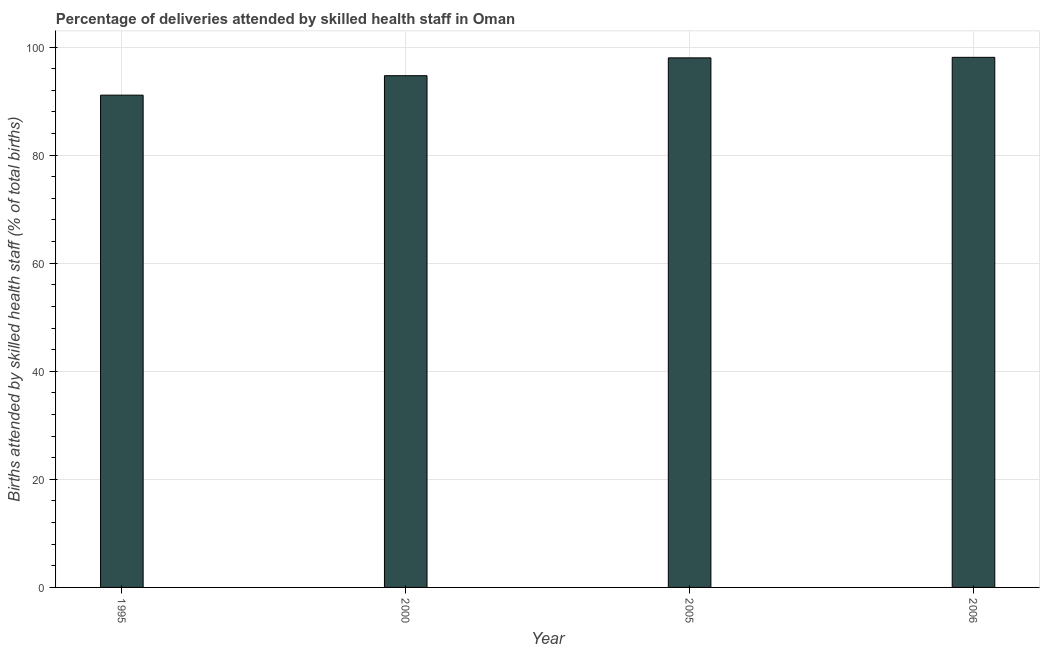Does the graph contain any zero values?
Offer a terse response. No. Does the graph contain grids?
Your answer should be compact. Yes. What is the title of the graph?
Provide a succinct answer. Percentage of deliveries attended by skilled health staff in Oman. What is the label or title of the X-axis?
Ensure brevity in your answer.  Year. What is the label or title of the Y-axis?
Give a very brief answer. Births attended by skilled health staff (% of total births). What is the number of births attended by skilled health staff in 2005?
Ensure brevity in your answer.  98. Across all years, what is the maximum number of births attended by skilled health staff?
Make the answer very short. 98.1. Across all years, what is the minimum number of births attended by skilled health staff?
Offer a very short reply. 91.1. In which year was the number of births attended by skilled health staff minimum?
Your answer should be compact. 1995. What is the sum of the number of births attended by skilled health staff?
Provide a short and direct response. 381.9. What is the difference between the number of births attended by skilled health staff in 2000 and 2006?
Ensure brevity in your answer.  -3.4. What is the average number of births attended by skilled health staff per year?
Offer a terse response. 95.47. What is the median number of births attended by skilled health staff?
Your answer should be compact. 96.35. What is the ratio of the number of births attended by skilled health staff in 1995 to that in 2006?
Provide a short and direct response. 0.93. Is the difference between the number of births attended by skilled health staff in 1995 and 2006 greater than the difference between any two years?
Your response must be concise. Yes. What is the difference between the highest and the second highest number of births attended by skilled health staff?
Your response must be concise. 0.1. In how many years, is the number of births attended by skilled health staff greater than the average number of births attended by skilled health staff taken over all years?
Offer a terse response. 2. How many bars are there?
Ensure brevity in your answer.  4. Are all the bars in the graph horizontal?
Give a very brief answer. No. What is the difference between two consecutive major ticks on the Y-axis?
Give a very brief answer. 20. What is the Births attended by skilled health staff (% of total births) in 1995?
Your response must be concise. 91.1. What is the Births attended by skilled health staff (% of total births) of 2000?
Offer a terse response. 94.7. What is the Births attended by skilled health staff (% of total births) of 2006?
Make the answer very short. 98.1. What is the difference between the Births attended by skilled health staff (% of total births) in 1995 and 2000?
Ensure brevity in your answer.  -3.6. What is the difference between the Births attended by skilled health staff (% of total births) in 1995 and 2005?
Offer a terse response. -6.9. What is the difference between the Births attended by skilled health staff (% of total births) in 1995 and 2006?
Make the answer very short. -7. What is the difference between the Births attended by skilled health staff (% of total births) in 2000 and 2005?
Keep it short and to the point. -3.3. What is the ratio of the Births attended by skilled health staff (% of total births) in 1995 to that in 2005?
Provide a short and direct response. 0.93. What is the ratio of the Births attended by skilled health staff (% of total births) in 1995 to that in 2006?
Offer a very short reply. 0.93. What is the ratio of the Births attended by skilled health staff (% of total births) in 2000 to that in 2006?
Give a very brief answer. 0.96. 